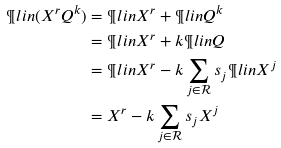Convert formula to latex. <formula><loc_0><loc_0><loc_500><loc_500>\P l i n ( X ^ { r } Q ^ { k } ) & = \P l i n X ^ { r } + \P l i n Q ^ { k } \\ & = \P l i n X ^ { r } + k \P l i n Q \\ & = \P l i n X ^ { r } - k \sum _ { j \in \mathcal { R } } s _ { j } \P l i n X ^ { j } \\ & = X ^ { r } - k \sum _ { j \in \mathcal { R } } s _ { j } X ^ { j }</formula> 